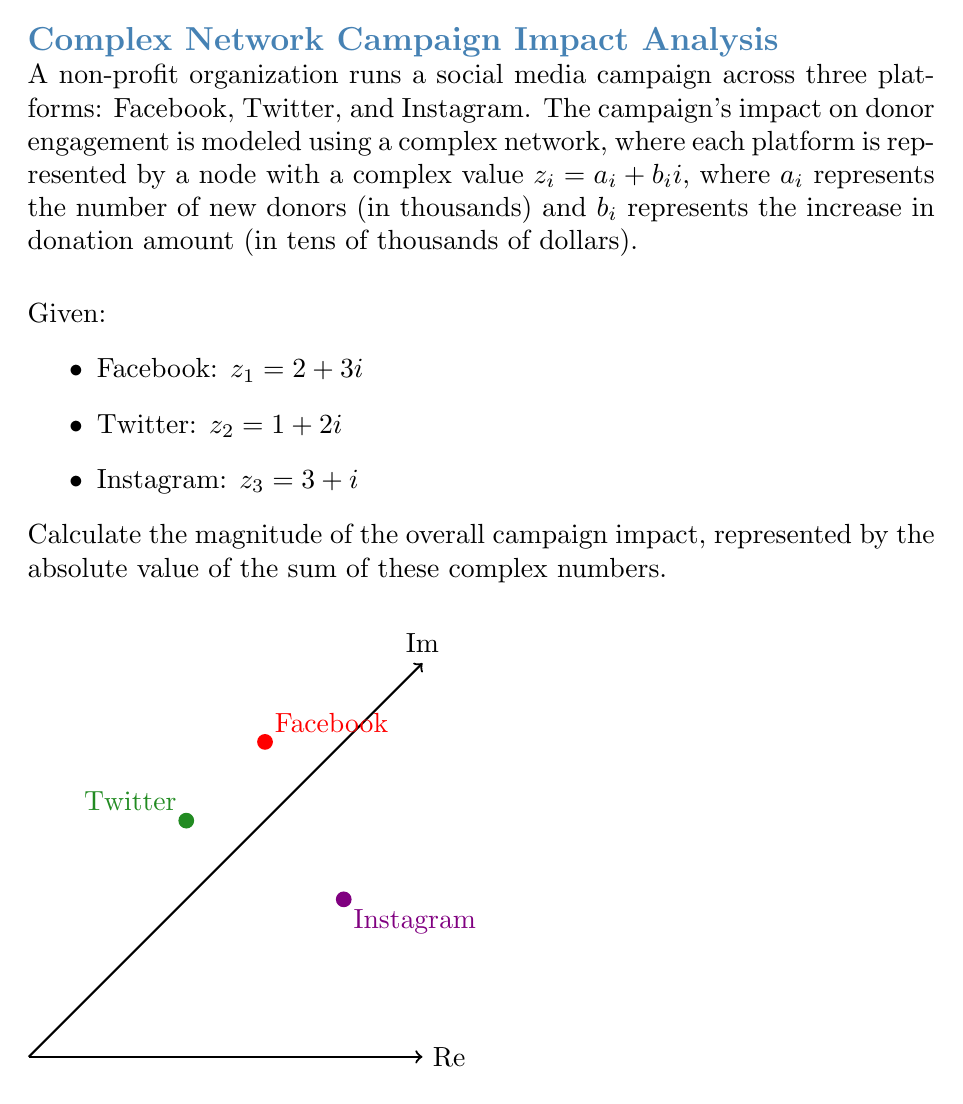Can you solve this math problem? Let's approach this step-by-step:

1) First, we need to sum the complex numbers representing each platform's impact:

   $z_{total} = z_1 + z_2 + z_3$

2) Substituting the given values:

   $z_{total} = (2 + 3i) + (1 + 2i) + (3 + i)$

3) Simplifying:

   $z_{total} = (2 + 1 + 3) + (3 + 2 + 1)i$
   $z_{total} = 6 + 6i$

4) To find the magnitude of the overall impact, we need to calculate the absolute value of $z_{total}$. For a complex number $z = a + bi$, its absolute value is given by:

   $|z| = \sqrt{a^2 + b^2}$

5) In this case:

   $|z_{total}| = \sqrt{6^2 + 6^2}$

6) Simplifying:

   $|z_{total}| = \sqrt{36 + 36} = \sqrt{72}$

7) Simplifying further:

   $|z_{total}| = 6\sqrt{2}$

This value represents the magnitude of the overall campaign impact, combining both the number of new donors and the increase in donation amount across all platforms.
Answer: $6\sqrt{2}$ 